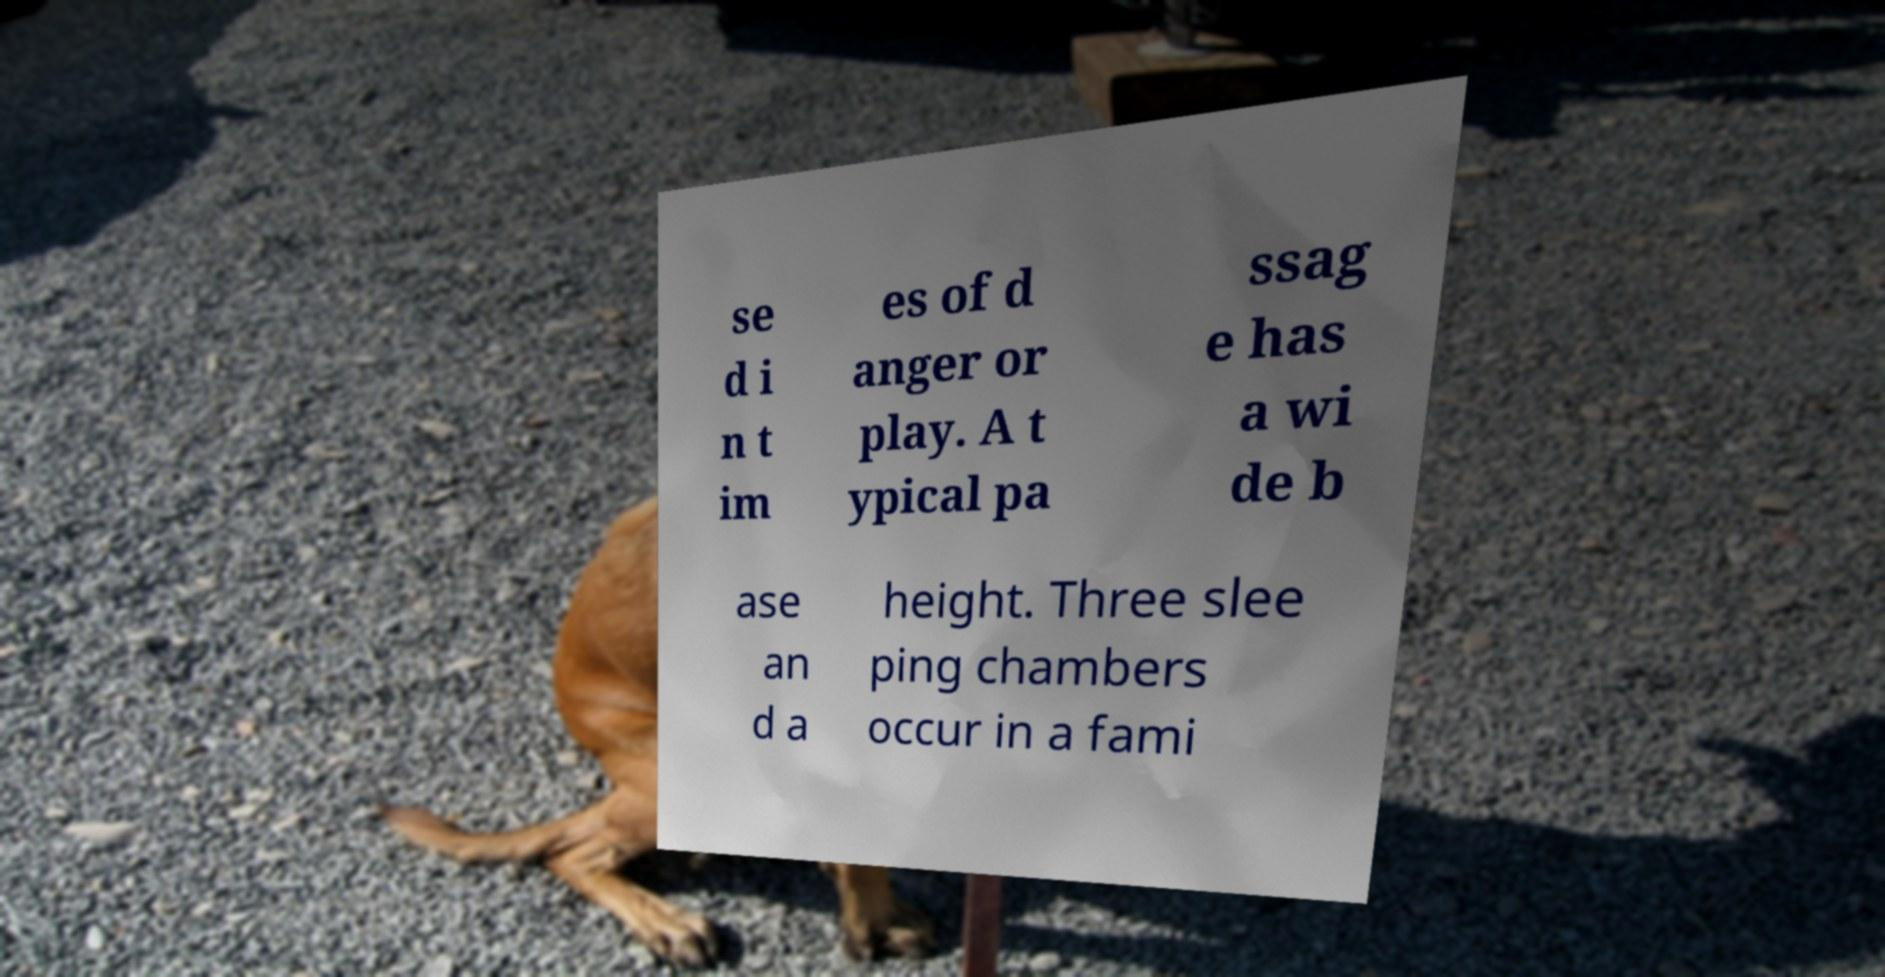There's text embedded in this image that I need extracted. Can you transcribe it verbatim? se d i n t im es of d anger or play. A t ypical pa ssag e has a wi de b ase an d a height. Three slee ping chambers occur in a fami 